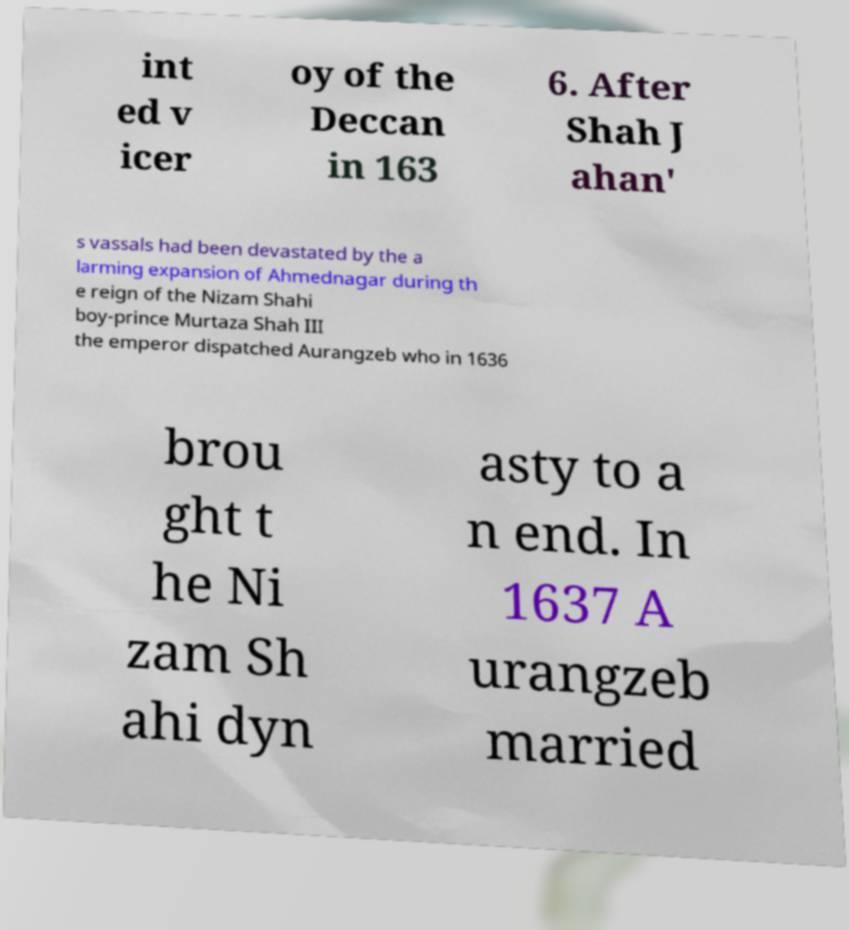What messages or text are displayed in this image? I need them in a readable, typed format. int ed v icer oy of the Deccan in 163 6. After Shah J ahan' s vassals had been devastated by the a larming expansion of Ahmednagar during th e reign of the Nizam Shahi boy-prince Murtaza Shah III the emperor dispatched Aurangzeb who in 1636 brou ght t he Ni zam Sh ahi dyn asty to a n end. In 1637 A urangzeb married 